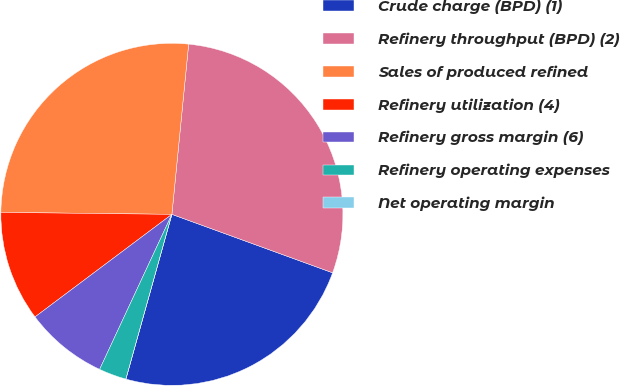Convert chart to OTSL. <chart><loc_0><loc_0><loc_500><loc_500><pie_chart><fcel>Crude charge (BPD) (1)<fcel>Refinery throughput (BPD) (2)<fcel>Sales of produced refined<fcel>Refinery utilization (4)<fcel>Refinery gross margin (6)<fcel>Refinery operating expenses<fcel>Net operating margin<nl><fcel>23.78%<fcel>28.99%<fcel>26.38%<fcel>10.42%<fcel>7.82%<fcel>2.61%<fcel>0.0%<nl></chart> 